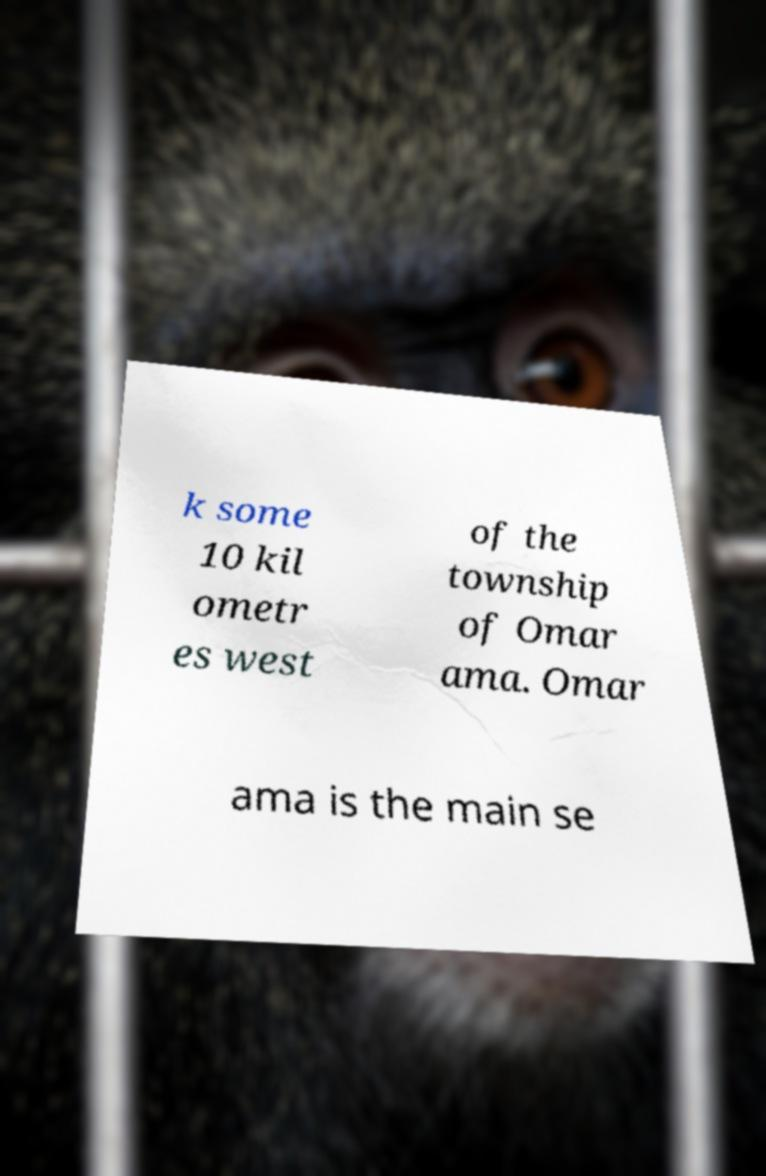Please read and relay the text visible in this image. What does it say? k some 10 kil ometr es west of the township of Omar ama. Omar ama is the main se 